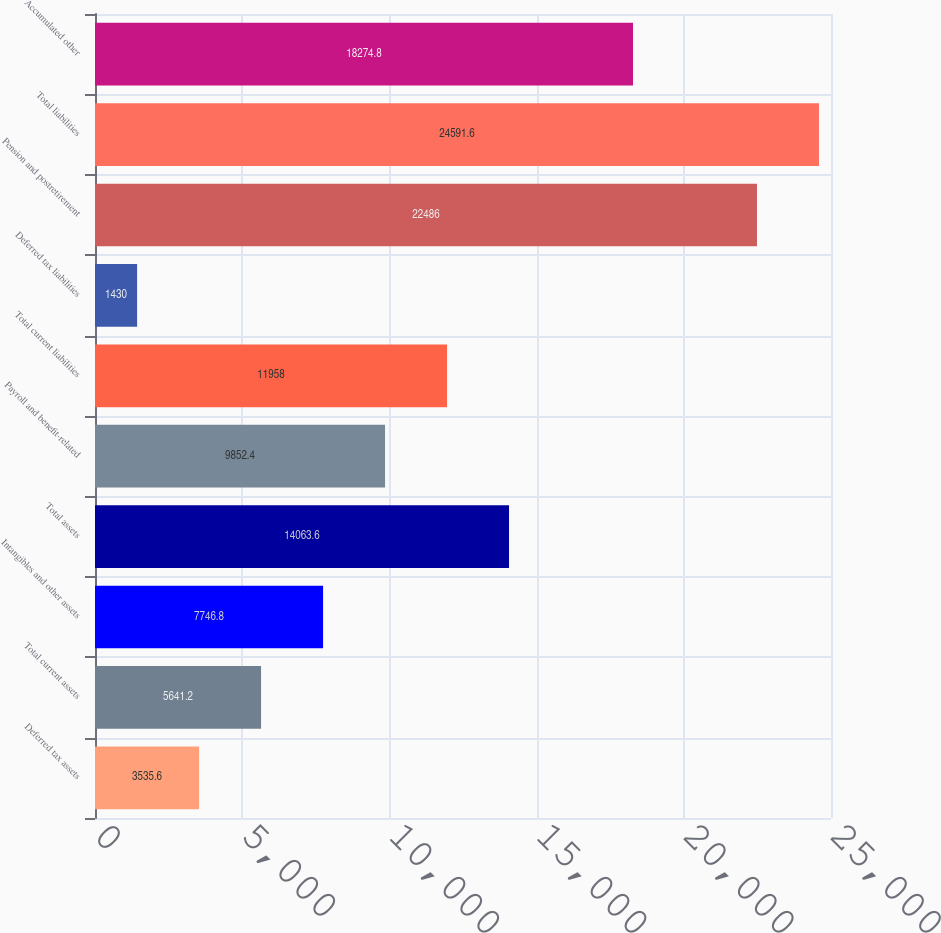<chart> <loc_0><loc_0><loc_500><loc_500><bar_chart><fcel>Deferred tax assets<fcel>Total current assets<fcel>Intangibles and other assets<fcel>Total assets<fcel>Payroll and benefit-related<fcel>Total current liabilities<fcel>Deferred tax liabilities<fcel>Pension and postretirement<fcel>Total liabilities<fcel>Accumulated other<nl><fcel>3535.6<fcel>5641.2<fcel>7746.8<fcel>14063.6<fcel>9852.4<fcel>11958<fcel>1430<fcel>22486<fcel>24591.6<fcel>18274.8<nl></chart> 